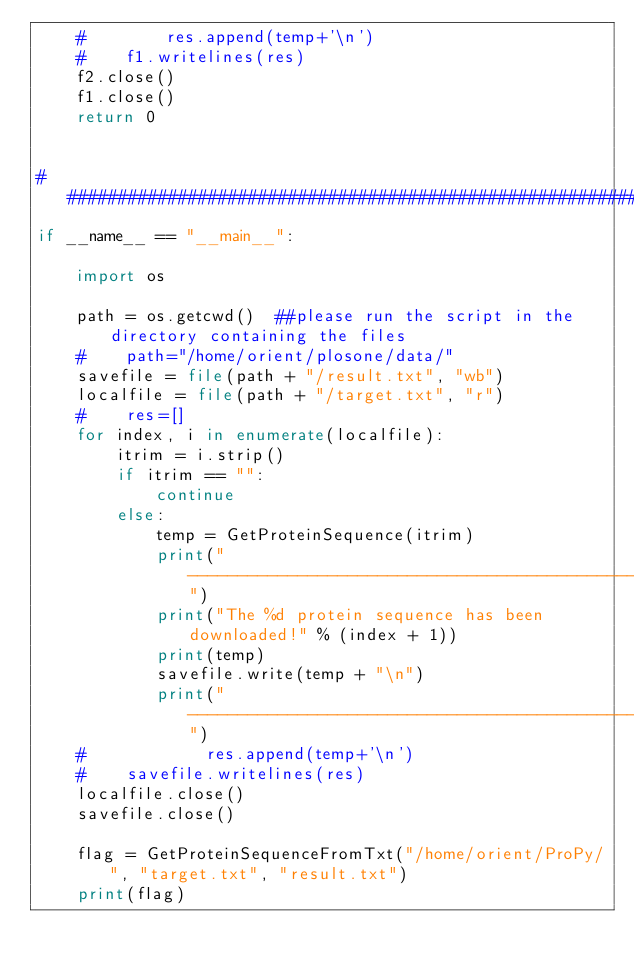<code> <loc_0><loc_0><loc_500><loc_500><_Python_>    #        res.append(temp+'\n')
    #    f1.writelines(res)
    f2.close()
    f1.close()
    return 0


##################################################################################################
if __name__ == "__main__":

    import os

    path = os.getcwd()  ##please run the script in the directory containing the files
    #    path="/home/orient/plosone/data/"
    savefile = file(path + "/result.txt", "wb")
    localfile = file(path + "/target.txt", "r")
    #    res=[]
    for index, i in enumerate(localfile):
        itrim = i.strip()
        if itrim == "":
            continue
        else:
            temp = GetProteinSequence(itrim)
            print("--------------------------------------------------------")
            print("The %d protein sequence has been downloaded!" % (index + 1))
            print(temp)
            savefile.write(temp + "\n")
            print("--------------------------------------------------------")
    #            res.append(temp+'\n')
    #    savefile.writelines(res)
    localfile.close()
    savefile.close()

    flag = GetProteinSequenceFromTxt("/home/orient/ProPy/", "target.txt", "result.txt")
    print(flag)
</code> 